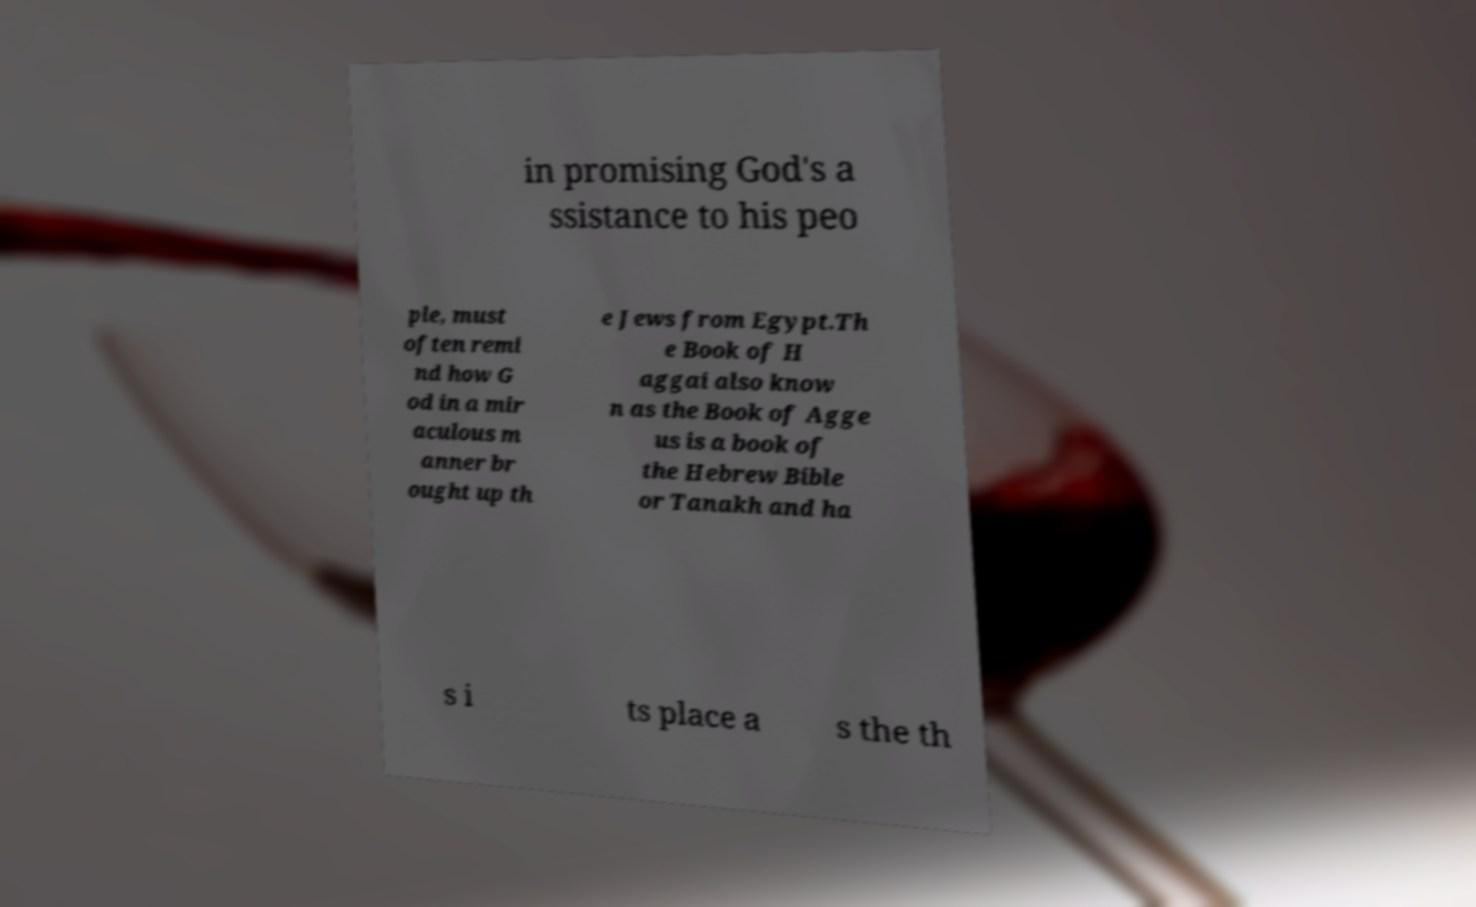I need the written content from this picture converted into text. Can you do that? in promising God's a ssistance to his peo ple, must often remi nd how G od in a mir aculous m anner br ought up th e Jews from Egypt.Th e Book of H aggai also know n as the Book of Agge us is a book of the Hebrew Bible or Tanakh and ha s i ts place a s the th 